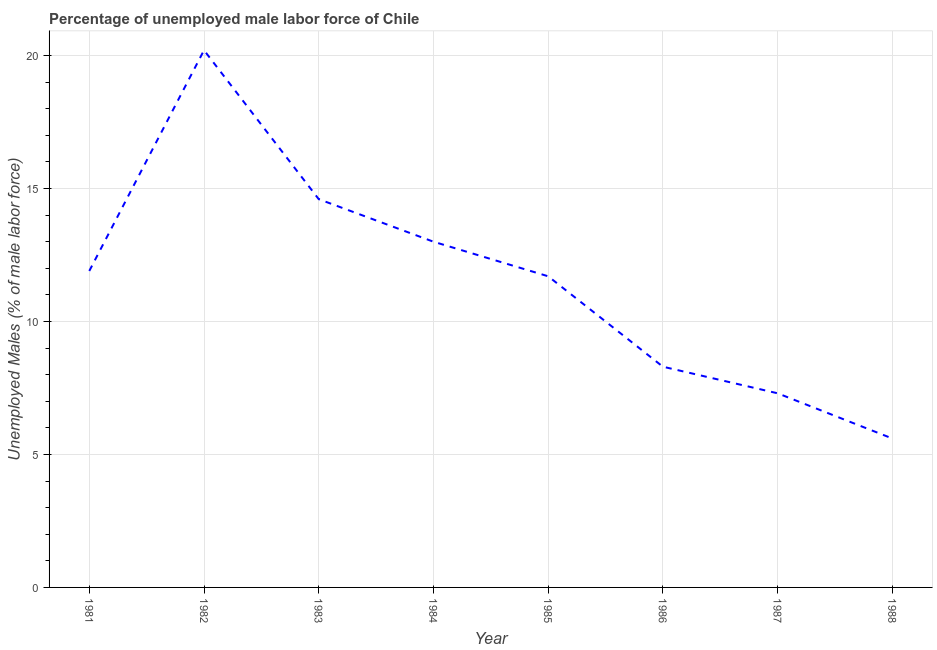What is the total unemployed male labour force in 1985?
Your answer should be very brief. 11.7. Across all years, what is the maximum total unemployed male labour force?
Your answer should be compact. 20.2. Across all years, what is the minimum total unemployed male labour force?
Your answer should be very brief. 5.6. In which year was the total unemployed male labour force maximum?
Provide a succinct answer. 1982. What is the sum of the total unemployed male labour force?
Offer a terse response. 92.6. What is the difference between the total unemployed male labour force in 1983 and 1988?
Your answer should be compact. 9. What is the average total unemployed male labour force per year?
Make the answer very short. 11.58. What is the median total unemployed male labour force?
Your response must be concise. 11.8. What is the ratio of the total unemployed male labour force in 1982 to that in 1985?
Ensure brevity in your answer.  1.73. Is the difference between the total unemployed male labour force in 1985 and 1986 greater than the difference between any two years?
Give a very brief answer. No. What is the difference between the highest and the second highest total unemployed male labour force?
Make the answer very short. 5.6. What is the difference between the highest and the lowest total unemployed male labour force?
Your response must be concise. 14.6. In how many years, is the total unemployed male labour force greater than the average total unemployed male labour force taken over all years?
Provide a succinct answer. 5. Does the total unemployed male labour force monotonically increase over the years?
Your response must be concise. No. How many years are there in the graph?
Your answer should be compact. 8. What is the difference between two consecutive major ticks on the Y-axis?
Your answer should be compact. 5. Are the values on the major ticks of Y-axis written in scientific E-notation?
Keep it short and to the point. No. What is the title of the graph?
Keep it short and to the point. Percentage of unemployed male labor force of Chile. What is the label or title of the Y-axis?
Your response must be concise. Unemployed Males (% of male labor force). What is the Unemployed Males (% of male labor force) of 1981?
Offer a very short reply. 11.9. What is the Unemployed Males (% of male labor force) in 1982?
Ensure brevity in your answer.  20.2. What is the Unemployed Males (% of male labor force) in 1983?
Give a very brief answer. 14.6. What is the Unemployed Males (% of male labor force) in 1985?
Your response must be concise. 11.7. What is the Unemployed Males (% of male labor force) in 1986?
Your answer should be very brief. 8.3. What is the Unemployed Males (% of male labor force) in 1987?
Provide a short and direct response. 7.3. What is the Unemployed Males (% of male labor force) in 1988?
Offer a very short reply. 5.6. What is the difference between the Unemployed Males (% of male labor force) in 1981 and 1984?
Offer a very short reply. -1.1. What is the difference between the Unemployed Males (% of male labor force) in 1981 and 1986?
Provide a succinct answer. 3.6. What is the difference between the Unemployed Males (% of male labor force) in 1981 and 1987?
Keep it short and to the point. 4.6. What is the difference between the Unemployed Males (% of male labor force) in 1981 and 1988?
Offer a terse response. 6.3. What is the difference between the Unemployed Males (% of male labor force) in 1984 and 1985?
Provide a short and direct response. 1.3. What is the difference between the Unemployed Males (% of male labor force) in 1984 and 1986?
Provide a short and direct response. 4.7. What is the difference between the Unemployed Males (% of male labor force) in 1985 and 1987?
Provide a succinct answer. 4.4. What is the difference between the Unemployed Males (% of male labor force) in 1986 and 1988?
Your response must be concise. 2.7. What is the difference between the Unemployed Males (% of male labor force) in 1987 and 1988?
Make the answer very short. 1.7. What is the ratio of the Unemployed Males (% of male labor force) in 1981 to that in 1982?
Offer a very short reply. 0.59. What is the ratio of the Unemployed Males (% of male labor force) in 1981 to that in 1983?
Provide a succinct answer. 0.81. What is the ratio of the Unemployed Males (% of male labor force) in 1981 to that in 1984?
Offer a very short reply. 0.92. What is the ratio of the Unemployed Males (% of male labor force) in 1981 to that in 1986?
Keep it short and to the point. 1.43. What is the ratio of the Unemployed Males (% of male labor force) in 1981 to that in 1987?
Provide a succinct answer. 1.63. What is the ratio of the Unemployed Males (% of male labor force) in 1981 to that in 1988?
Offer a very short reply. 2.12. What is the ratio of the Unemployed Males (% of male labor force) in 1982 to that in 1983?
Give a very brief answer. 1.38. What is the ratio of the Unemployed Males (% of male labor force) in 1982 to that in 1984?
Provide a short and direct response. 1.55. What is the ratio of the Unemployed Males (% of male labor force) in 1982 to that in 1985?
Offer a very short reply. 1.73. What is the ratio of the Unemployed Males (% of male labor force) in 1982 to that in 1986?
Your answer should be very brief. 2.43. What is the ratio of the Unemployed Males (% of male labor force) in 1982 to that in 1987?
Offer a very short reply. 2.77. What is the ratio of the Unemployed Males (% of male labor force) in 1982 to that in 1988?
Make the answer very short. 3.61. What is the ratio of the Unemployed Males (% of male labor force) in 1983 to that in 1984?
Ensure brevity in your answer.  1.12. What is the ratio of the Unemployed Males (% of male labor force) in 1983 to that in 1985?
Offer a very short reply. 1.25. What is the ratio of the Unemployed Males (% of male labor force) in 1983 to that in 1986?
Give a very brief answer. 1.76. What is the ratio of the Unemployed Males (% of male labor force) in 1983 to that in 1988?
Your answer should be very brief. 2.61. What is the ratio of the Unemployed Males (% of male labor force) in 1984 to that in 1985?
Give a very brief answer. 1.11. What is the ratio of the Unemployed Males (% of male labor force) in 1984 to that in 1986?
Ensure brevity in your answer.  1.57. What is the ratio of the Unemployed Males (% of male labor force) in 1984 to that in 1987?
Offer a terse response. 1.78. What is the ratio of the Unemployed Males (% of male labor force) in 1984 to that in 1988?
Your answer should be compact. 2.32. What is the ratio of the Unemployed Males (% of male labor force) in 1985 to that in 1986?
Provide a succinct answer. 1.41. What is the ratio of the Unemployed Males (% of male labor force) in 1985 to that in 1987?
Your answer should be compact. 1.6. What is the ratio of the Unemployed Males (% of male labor force) in 1985 to that in 1988?
Keep it short and to the point. 2.09. What is the ratio of the Unemployed Males (% of male labor force) in 1986 to that in 1987?
Make the answer very short. 1.14. What is the ratio of the Unemployed Males (% of male labor force) in 1986 to that in 1988?
Your answer should be very brief. 1.48. What is the ratio of the Unemployed Males (% of male labor force) in 1987 to that in 1988?
Provide a short and direct response. 1.3. 